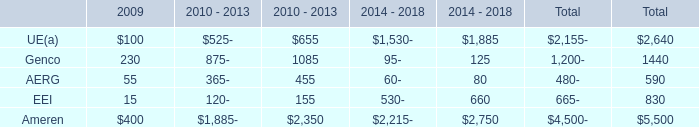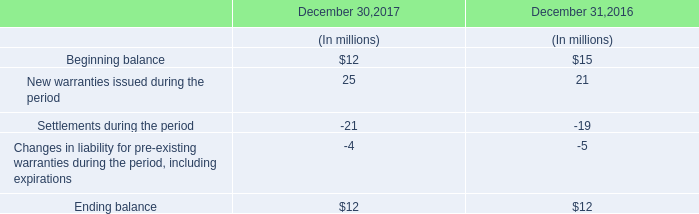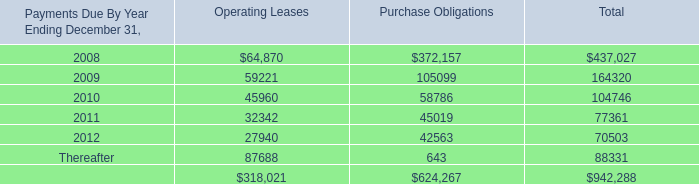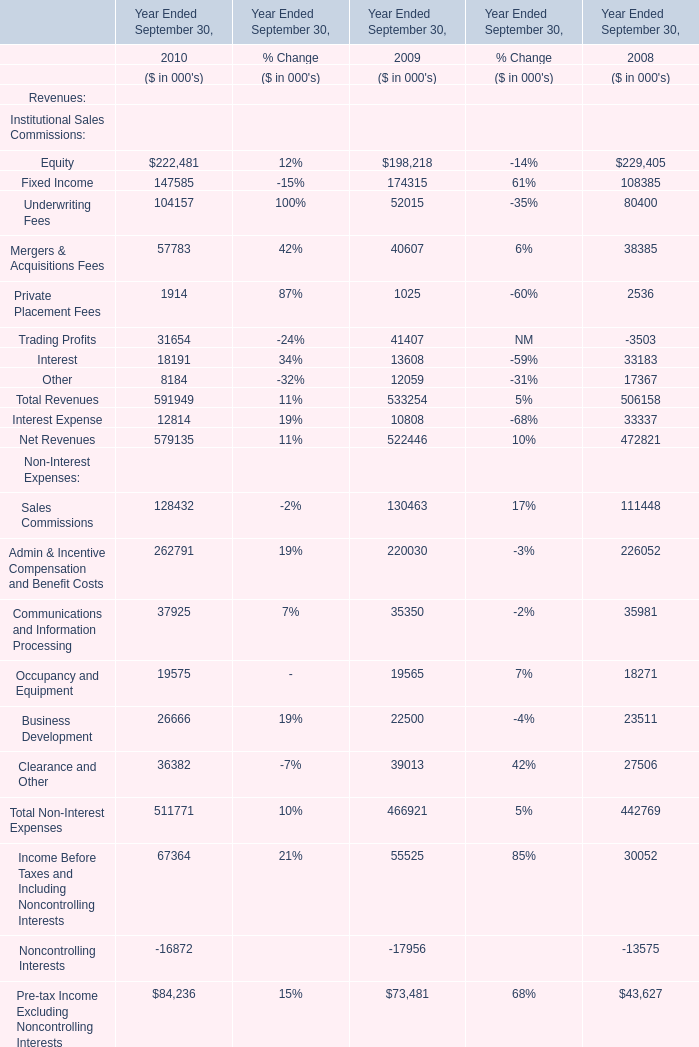Between 2009 and 2010,the Net Revenues in which Year Ended September 30 ranks first? 
Answer: 2010. 